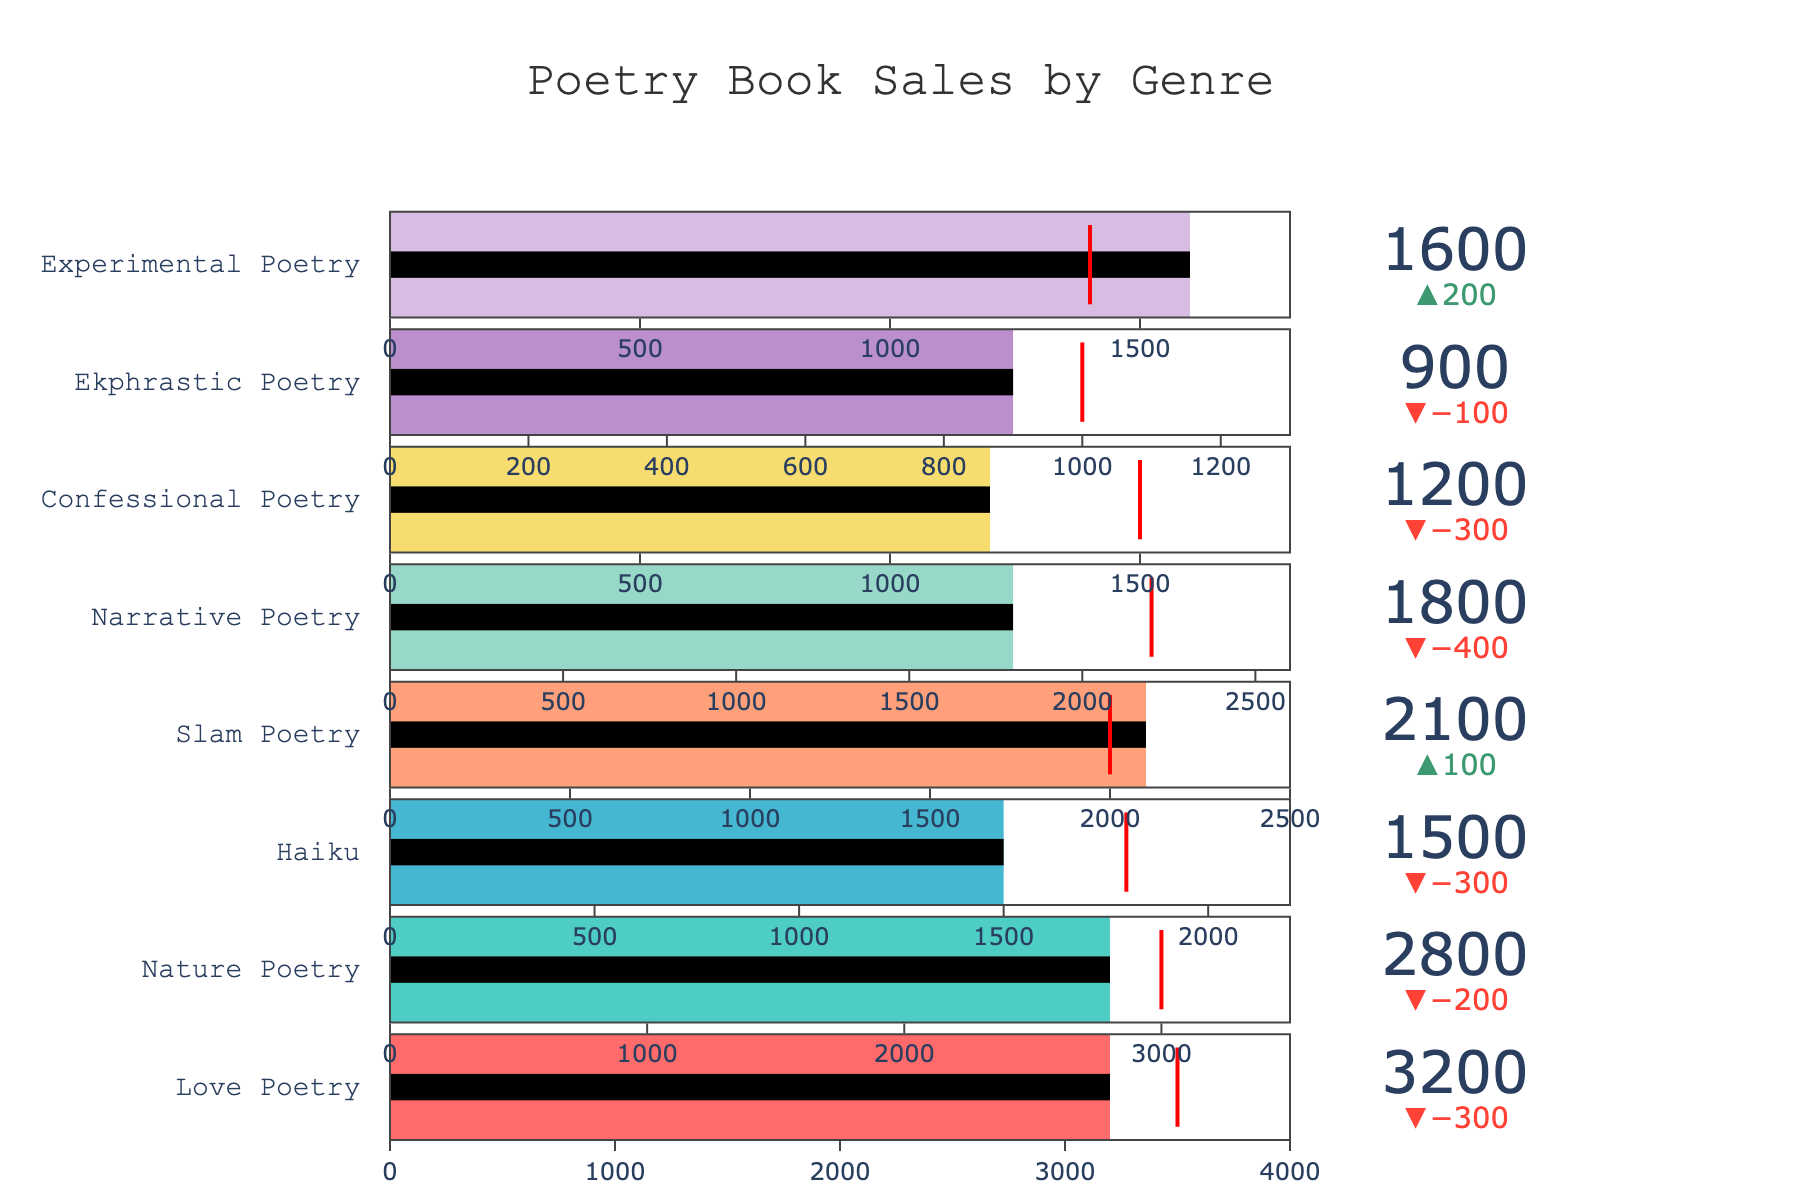What's the actual sales value for Love Poetry? The figure shows the actual sales represented on the bullet chart for Love Poetry. Look for the number indicated on the Love Poetry section at the top.
Answer: 3200 What's the difference between the actual sales and the target sales for Narrative Poetry? Identify the actual sales and target sales values for Narrative Poetry. Subtract the actual sales value from the target sales value.
Answer: -400 Which genre met its target sales? Review the delta indicators in the chart. Slam Poetry has actual sales higher than or equal to its target, indicating it met or exceeded its target.
Answer: Slam Poetry What is the percentage of the target achieved by Experimental Poetry? Divide the actual sales of Experimental Poetry (1600) by its target sales (1400), and multiply by 100 to get the percentage.
Answer: 114.29% How many genres have actual sales below their target values? Look at the delta indicators for each genre to determine whether they are negative. Count the genres where the actual sales are below the target.
Answer: 6 Which genre has the highest maximum sale value? Check the maximum values provided for each genre. The highest maximum value corresponds to Love Poetry.
Answer: Love Poetry What's the sum of the target sales for Love Poetry and Nature Poetry? Add the target sales values of both Love Poetry (3500) and Nature Poetry (3000).
Answer: 6500 Compare the actual sales of Haiku and Confessional Poetry. Which one is higher? Look at the actual sales values for both Haiku and Confessional Poetry. Haiku has a higher value.
Answer: Haiku What is the color associated with the bar for Ekphrastic Poetry? Each genre's bar color is coded. The bar for Ekphrastic Poetry is shaded in purple.
Answer: purple What is the smallest delta value in the chart, and for which genre is it? Review the delta values next to the actual sales of each genre. The smallest (most negative) delta value is for Confessional Poetry.
Answer: -300 